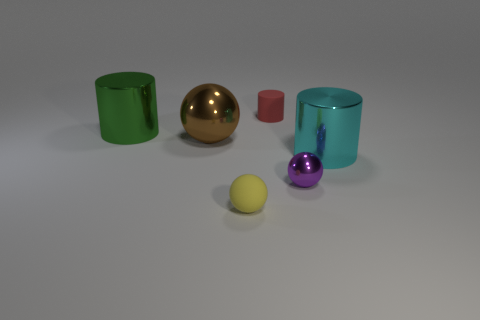Add 1 matte spheres. How many objects exist? 7 Add 1 yellow rubber spheres. How many yellow rubber spheres are left? 2 Add 5 small yellow shiny things. How many small yellow shiny things exist? 5 Subtract 0 red spheres. How many objects are left? 6 Subtract all large green objects. Subtract all big brown metallic objects. How many objects are left? 4 